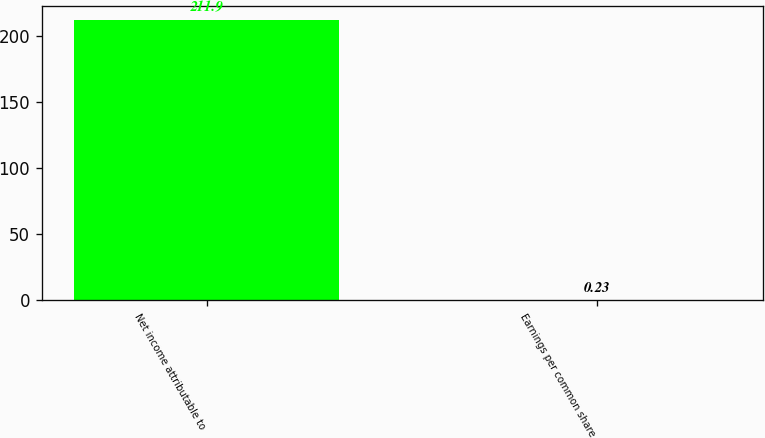<chart> <loc_0><loc_0><loc_500><loc_500><bar_chart><fcel>Net income attributable to<fcel>Earnings per common share<nl><fcel>211.9<fcel>0.23<nl></chart> 